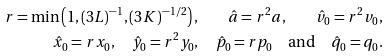<formula> <loc_0><loc_0><loc_500><loc_500>r = \min \left ( 1 , ( 3 L ) ^ { - 1 } , ( 3 K ) ^ { - 1 / 2 } \right ) , \quad \hat { a } = r ^ { 2 } a , \quad \hat { v } _ { 0 } = r ^ { 2 } v _ { 0 } , \\ \hat { x } _ { 0 } = r x _ { 0 } , \quad \hat { y } _ { 0 } = r ^ { 2 } y _ { 0 } , \quad \hat { p } _ { 0 } = r p _ { 0 } \quad \text {and} \quad \hat { q } _ { 0 } = q _ { 0 } .</formula> 